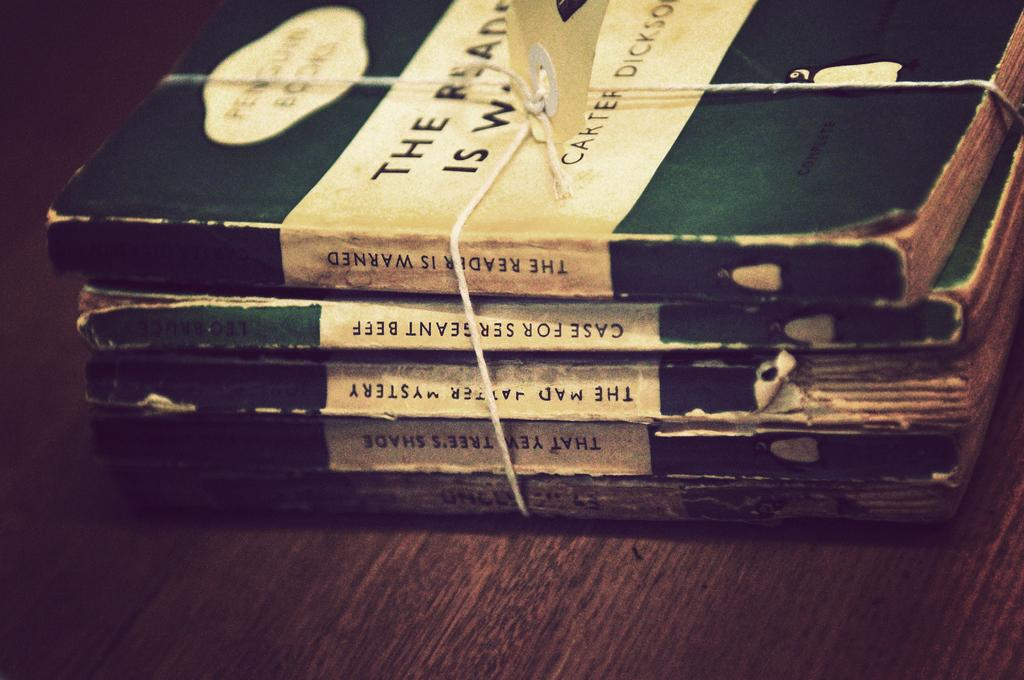Provide a one-sentence caption for the provided image. Five old paperbacks are bundled with string, including Case For Sergeant Beef. 